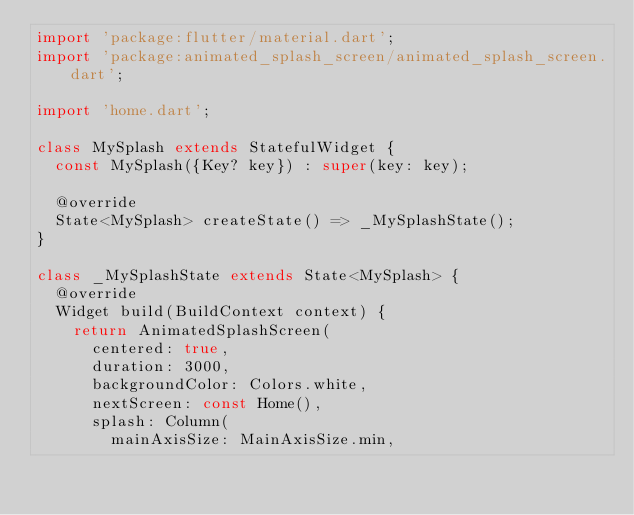<code> <loc_0><loc_0><loc_500><loc_500><_Dart_>import 'package:flutter/material.dart';
import 'package:animated_splash_screen/animated_splash_screen.dart';

import 'home.dart';

class MySplash extends StatefulWidget {
  const MySplash({Key? key}) : super(key: key);

  @override
  State<MySplash> createState() => _MySplashState();
}

class _MySplashState extends State<MySplash> {
  @override
  Widget build(BuildContext context) {
    return AnimatedSplashScreen(
      centered: true,
      duration: 3000,
      backgroundColor: Colors.white,
      nextScreen: const Home(),
      splash: Column(
        mainAxisSize: MainAxisSize.min,</code> 